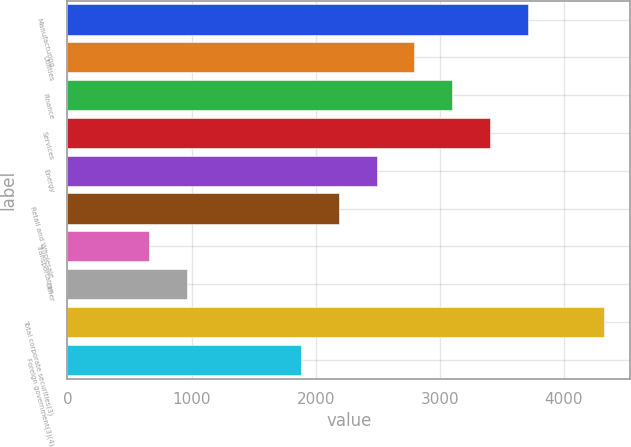Convert chart. <chart><loc_0><loc_0><loc_500><loc_500><bar_chart><fcel>Manufacturing<fcel>Utilities<fcel>Finance<fcel>Services<fcel>Energy<fcel>Retail and Wholesale<fcel>Transportation<fcel>Other<fcel>Total corporate securities(3)<fcel>Foreign government(3)(4)<nl><fcel>3709.8<fcel>2795.1<fcel>3100<fcel>3404.9<fcel>2490.2<fcel>2185.3<fcel>660.8<fcel>965.7<fcel>4319.6<fcel>1880.4<nl></chart> 